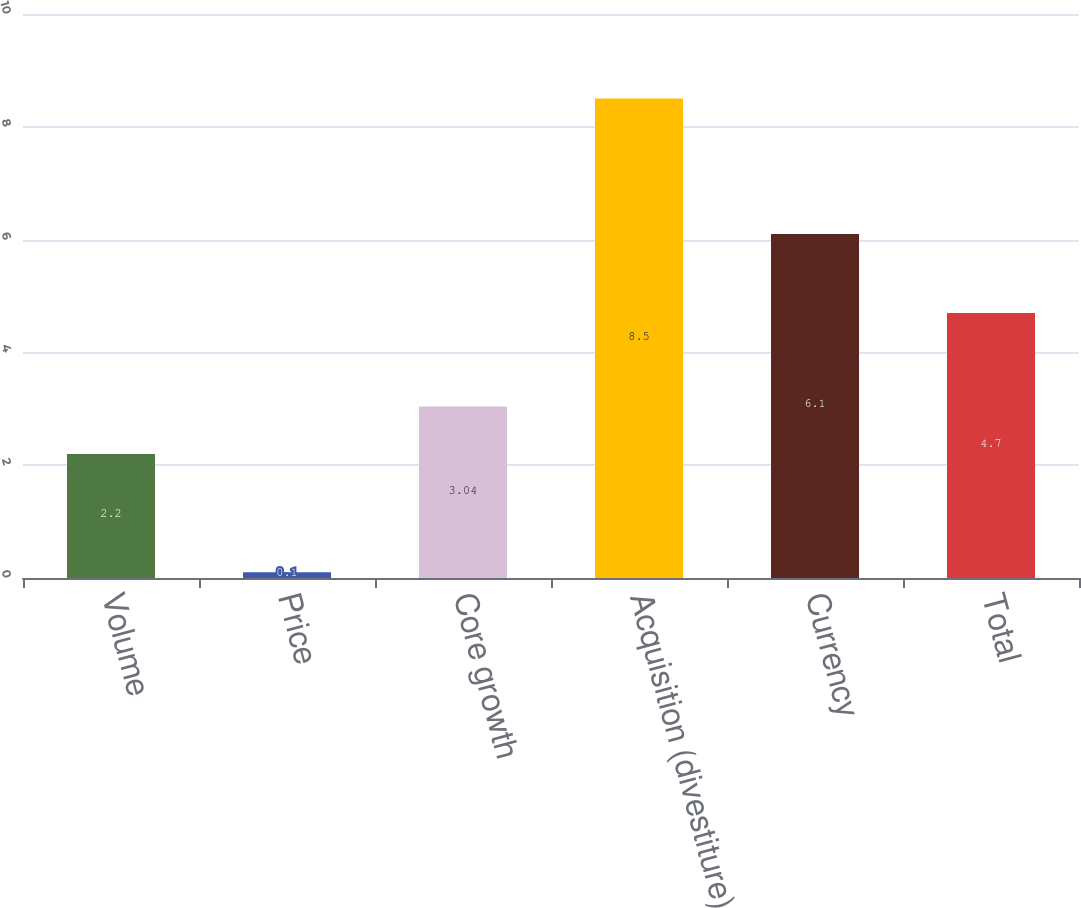Convert chart. <chart><loc_0><loc_0><loc_500><loc_500><bar_chart><fcel>Volume<fcel>Price<fcel>Core growth<fcel>Acquisition (divestiture)<fcel>Currency<fcel>Total<nl><fcel>2.2<fcel>0.1<fcel>3.04<fcel>8.5<fcel>6.1<fcel>4.7<nl></chart> 